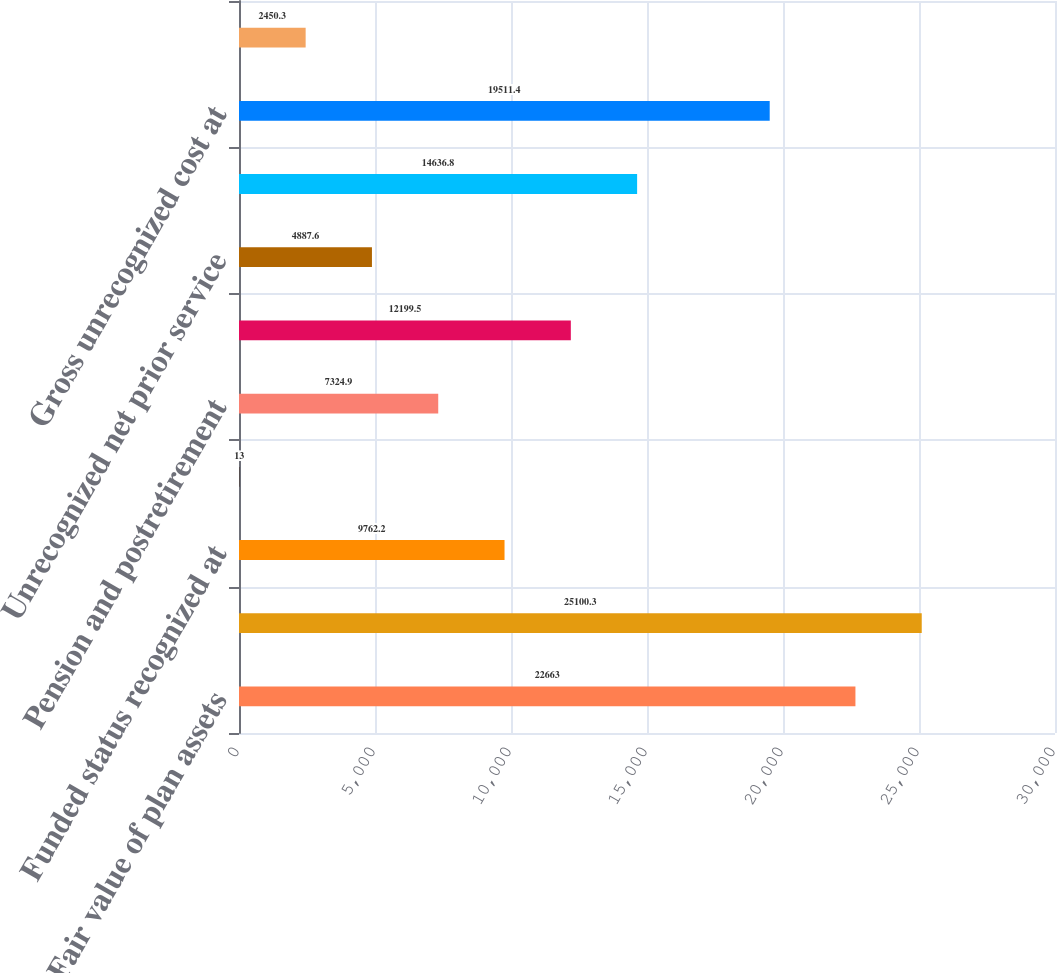Convert chart. <chart><loc_0><loc_0><loc_500><loc_500><bar_chart><fcel>Fair value of plan assets<fcel>Benefit obligation<fcel>Funded status recognized at<fcel>Other current liabilities<fcel>Pension and postretirement<fcel>Net liability at December 31<fcel>Unrecognized net prior service<fcel>Unrecognized net actuarial<fcel>Gross unrecognized cost at<fcel>Deferred tax asset at December<nl><fcel>22663<fcel>25100.3<fcel>9762.2<fcel>13<fcel>7324.9<fcel>12199.5<fcel>4887.6<fcel>14636.8<fcel>19511.4<fcel>2450.3<nl></chart> 